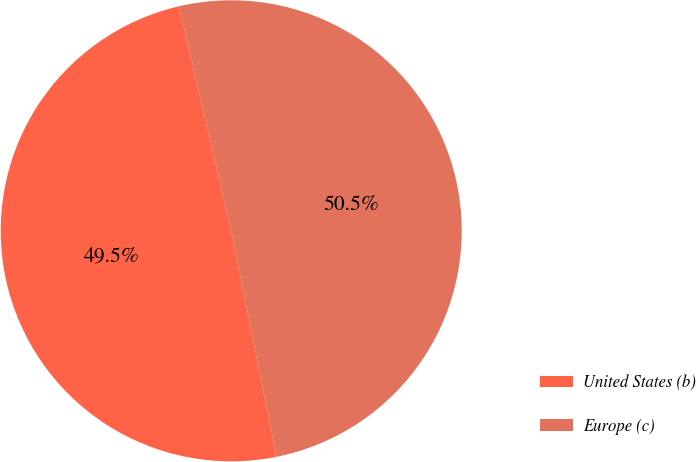Convert chart to OTSL. <chart><loc_0><loc_0><loc_500><loc_500><pie_chart><fcel>United States (b)<fcel>Europe (c)<nl><fcel>49.51%<fcel>50.49%<nl></chart> 